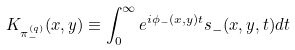Convert formula to latex. <formula><loc_0><loc_0><loc_500><loc_500>K _ { \pi ^ { ( q ) } _ { - } } ( x , y ) \equiv \int ^ { \infty } _ { 0 } e ^ { i \phi _ { - } ( x , y ) t } s _ { - } ( x , y , t ) d t</formula> 